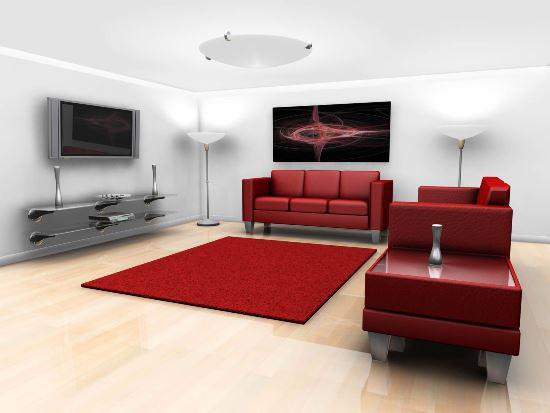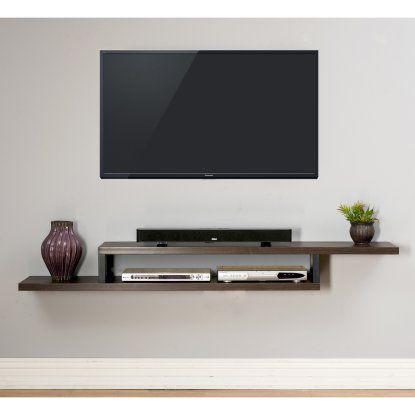The first image is the image on the left, the second image is the image on the right. Evaluate the accuracy of this statement regarding the images: "In at least one image there is a TV mounted to a shelf with a tall back over a long cabinet.". Is it true? Answer yes or no. No. The first image is the image on the left, the second image is the image on the right. Considering the images on both sides, is "At least one television is on." valid? Answer yes or no. No. 